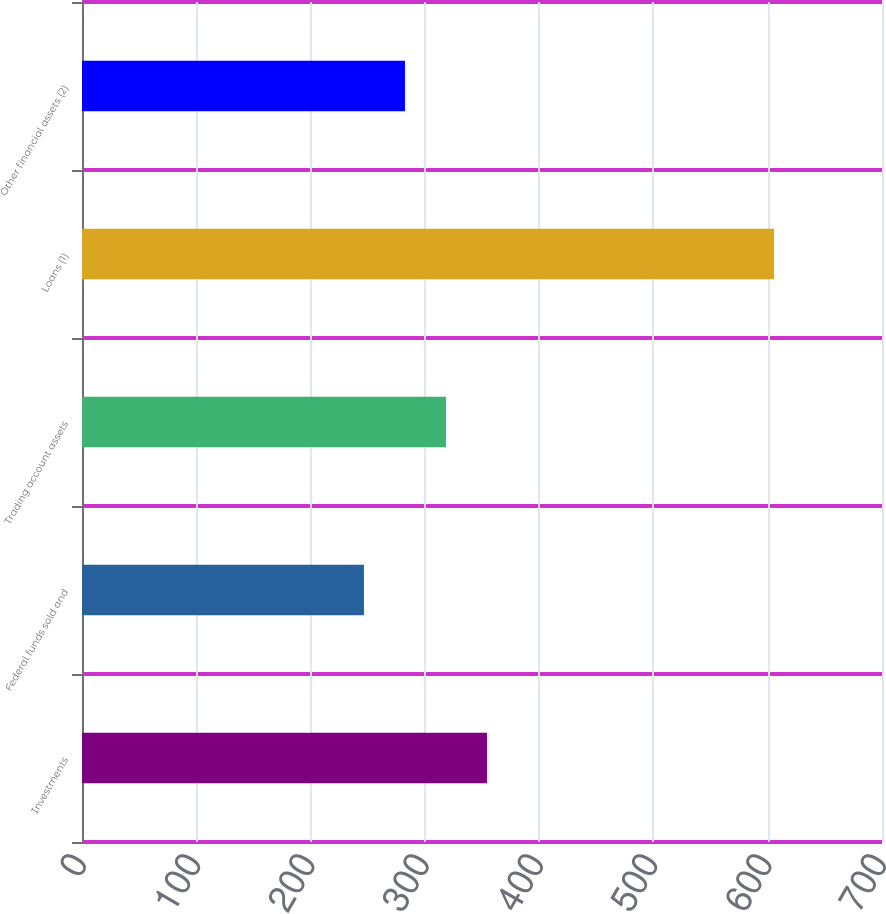<chart> <loc_0><loc_0><loc_500><loc_500><bar_chart><fcel>Investments<fcel>Federal funds sold and<fcel>Trading account assets<fcel>Loans (1)<fcel>Other financial assets (2)<nl><fcel>354.34<fcel>246.7<fcel>318.46<fcel>605.5<fcel>282.58<nl></chart> 